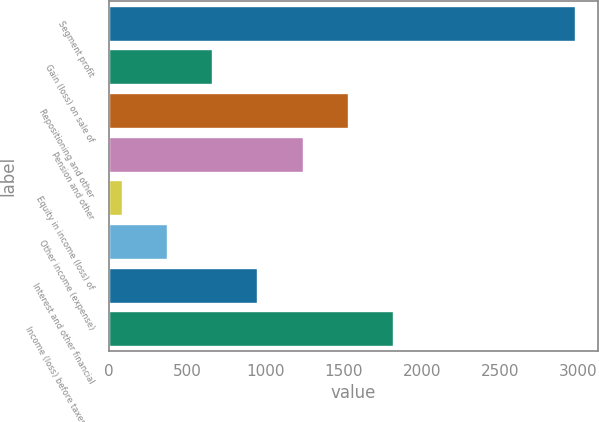Convert chart. <chart><loc_0><loc_0><loc_500><loc_500><bar_chart><fcel>Segment profit<fcel>Gain (loss) on sale of<fcel>Repositioning and other<fcel>Pension and other<fcel>Equity in income (loss) of<fcel>Other income (expense)<fcel>Interest and other financial<fcel>Income (loss) before taxes and<nl><fcel>2974<fcel>660.4<fcel>1528<fcel>1238.8<fcel>82<fcel>371.2<fcel>949.6<fcel>1817.2<nl></chart> 